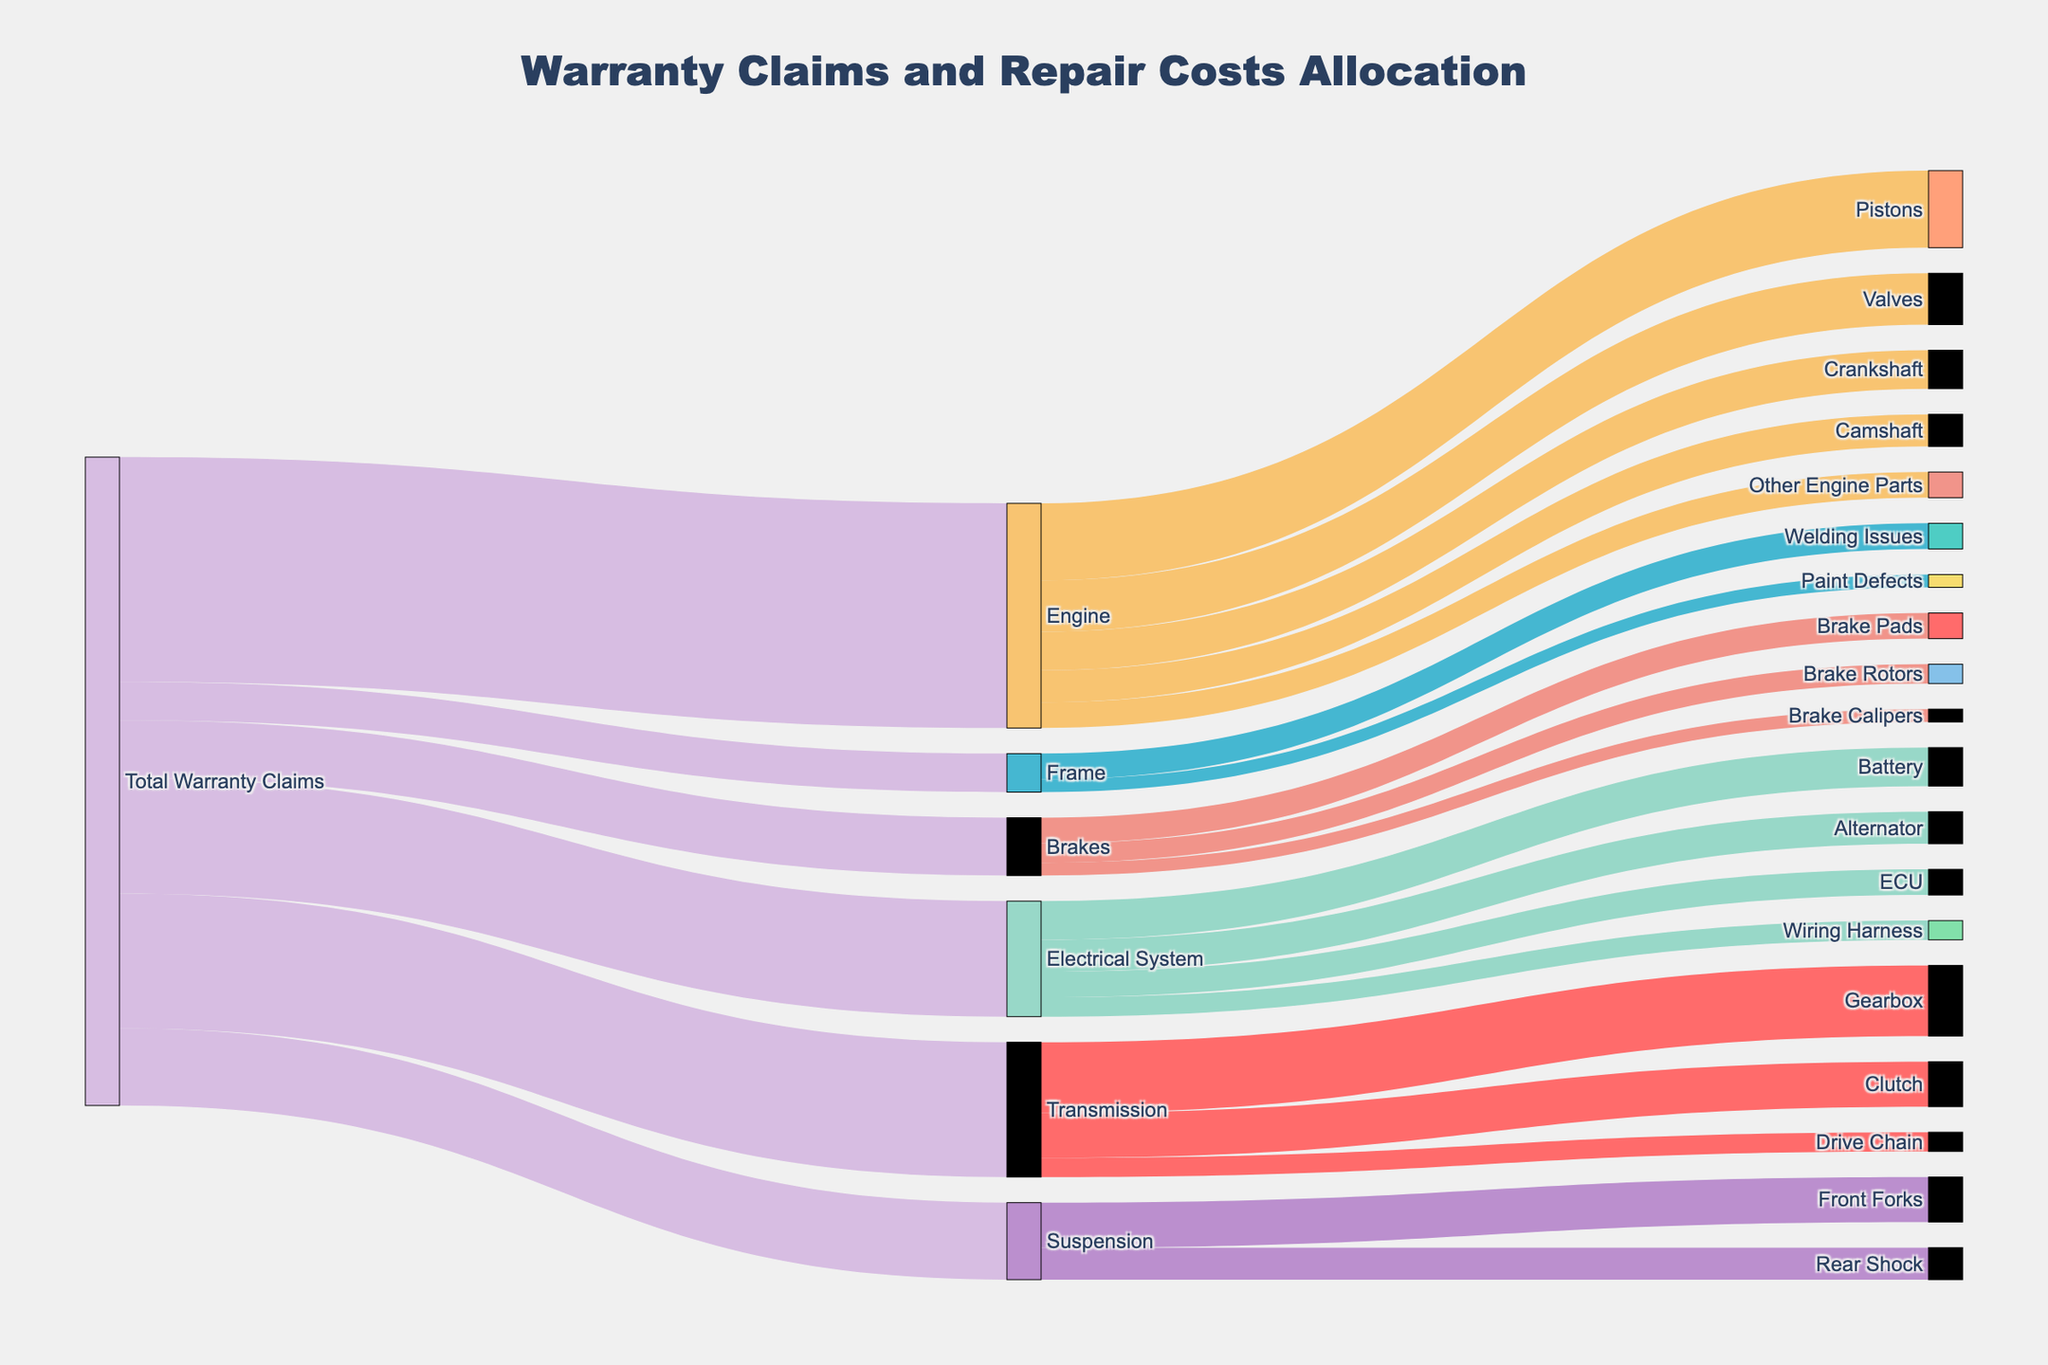What is the total number of warranty claims for the Engine? Look at the flow from "Total Warranty Claims" to "Engine" in the Sankey diagram, and observe the value. The value is 3500
Answer: 3500 How many claims are related to Brakes? Locate the flow from "Total Warranty Claims" to "Brakes" in the Sankey diagram and observe the value. The value is 900
Answer: 900 Which component under the Transmission category has the highest number of claims? Check the branches under "Transmission" and compare their values. Gearbox has the highest value, which is 1100
Answer: Gearbox What is the sum of claims for Electrical System components? Sum the values for Battery (600), Alternator (500), ECU (400), and Wiring Harness (300): 600 + 500 + 400 + 300 = 1800
Answer: 1800 What is the combined claim value for Pistons and Valves in the Engine? Find the values for Pistons (1200) and Valves (800), then add them: 1200 + 800 = 2000
Answer: 2000 Are there more claims for Gearbox or Clutch in the Transmission category? Compare the values for Gearbox (1100) and Clutch (700). Gearbox has more claims
Answer: Gearbox What is the proportion of total warranty claims that are related to Suspension? Divide the claims for Suspension (1200) by the total warranty claims (3500 + 2100 + 1800 + 1200 + 900 + 600= 10100) and multiply by 100: (1200 / 10100) * 100 ≈ 11.88%
Answer: ≈ 11.88% How many more claims does the Brake Pads have compared to Brake Calipers? Find the difference between Brake Pads (400) and Brake Calipers (200): 400 - 200 = 200
Answer: 200 Which category contributes more to warranty claims: Engine or Electrical System? Compare the values for Engine (3500) and Electrical System (1800). Engine has more claims
Answer: Engine 